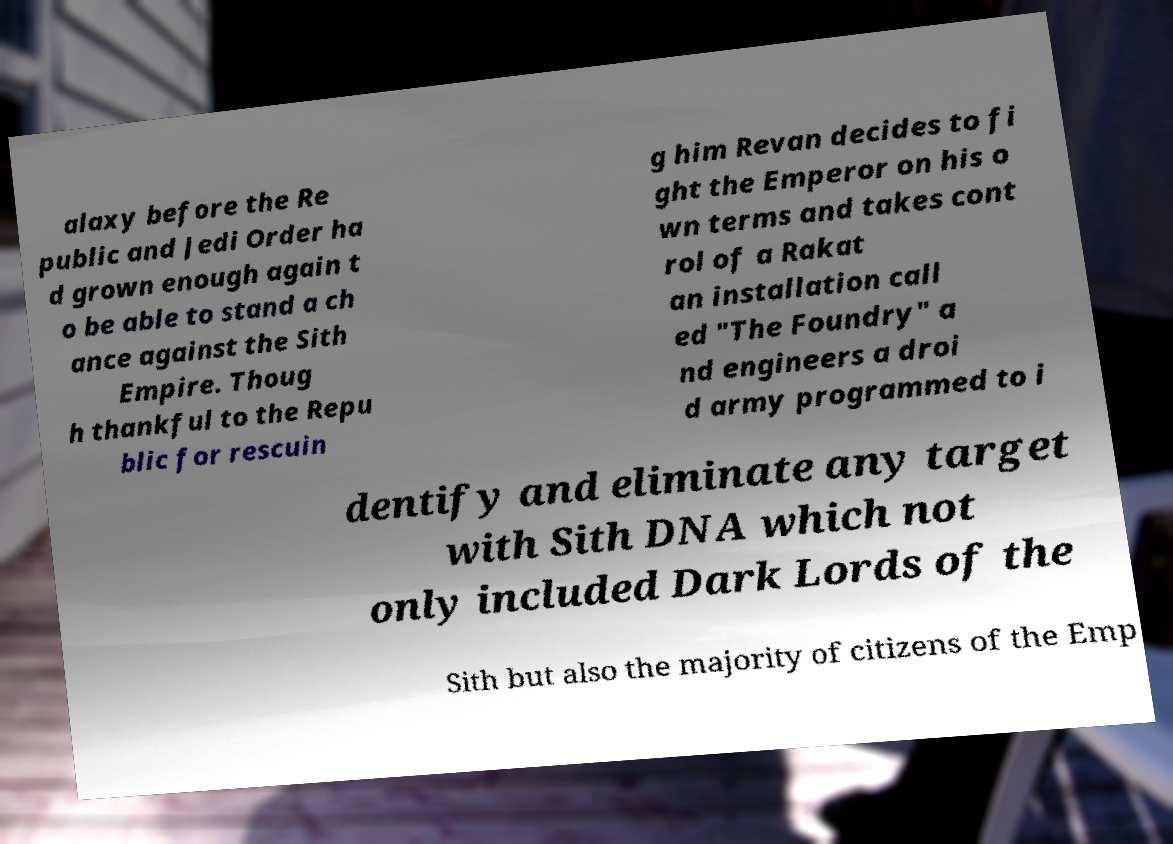What messages or text are displayed in this image? I need them in a readable, typed format. alaxy before the Re public and Jedi Order ha d grown enough again t o be able to stand a ch ance against the Sith Empire. Thoug h thankful to the Repu blic for rescuin g him Revan decides to fi ght the Emperor on his o wn terms and takes cont rol of a Rakat an installation call ed "The Foundry" a nd engineers a droi d army programmed to i dentify and eliminate any target with Sith DNA which not only included Dark Lords of the Sith but also the majority of citizens of the Emp 